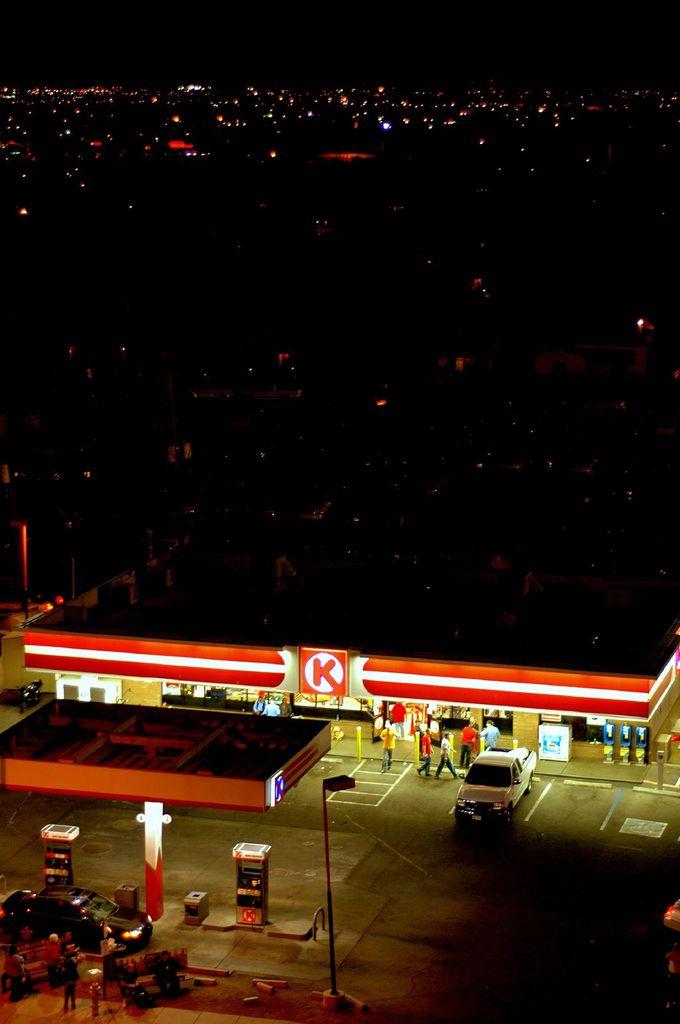What letter is on the gas station?
Give a very brief answer. K. 